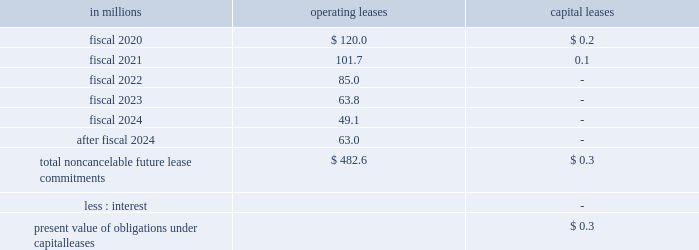As of may 26 , 2019 , we expect to pay approximately $ 2.0 million of unrecognized tax benefit liabilities and accrued interest within the next 12 months .
We are not able to reasonably estimate the timing of future cash flows beyond 12 months due to uncertainties in the timing of tax audit outcomes .
The remaining amount of our unrecognized tax liability was classified in other liabilities .
We report accrued interest and penalties related to unrecognized tax benefit liabilities in income tax expense .
For fiscal 2019 , we recognized $ 0.5 million of tax-related net interest and penalties , and had $ 26.0 million of accrued interest and penalties as of may 26 , 2019 .
For fiscal 2018 , we recognized a net benefit of $ 3.1 million of tax-related net interest and penalties , and had $ 27.3 million of accrued interest and penalties as of may 27 , 2018 .
Note 15 .
Leases , other commitments , and contingencies our leases are generally for warehouse space and equipment .
Rent expense under all operating leases from continuing operations was $ 184.9 million in fiscal 2019 , $ 189.4 million in fiscal 2018 , and $ 188.1 million in fiscal 2017 .
Some operating leases require payment of property taxes , insurance , and maintenance costs in addition to the rent payments .
Contingent and escalation rent in excess of minimum rent payments and sublease income netted in rent expense were insignificant .
Noncancelable future lease commitments are : in millions operating leases capital leases .
Depreciation on capital leases is recorded as depreciation expense in our results of operations .
As of may 26 , 2019 , we have issued guarantees and comfort letters of $ 681.6 million for the debt and other obligations of consolidated subsidiaries , and guarantees and comfort letters of $ 133.9 million for the debt and other obligations of non-consolidated affiliates , mainly cpw .
In addition , off-balance sheet arrangements are generally limited to the future payments under non-cancelable operating leases , which totaled $ 482.6 million as of may 26 , 2019 .
Note 16 .
Business segment and geographic information we operate in the packaged foods industry .
Our operating segments are as follows : north america retail ; convenience stores & foodservice ; europe & australia ; asia & latin america ; and pet .
Our north america retail operating segment reflects business with a wide variety of grocery stores , mass merchandisers , membership stores , natural food chains , drug , dollar and discount chains , and e-commerce grocery providers .
Our product categories in this business segment are ready-to-eat cereals , refrigerated yogurt , soup , meal kits , refrigerated and frozen dough products , dessert and baking mixes , frozen pizza and pizza snacks , grain , fruit and savory snacks , and a wide variety of organic products including refrigerated yogurt , nutrition bars , meal kits , salty snacks , ready-to-eat cereal , and grain snacks. .
In 2019 what was the percent of the total noncancelable future lease commitments that was due in 2021? 
Computations: (101.7 / 482.6)
Answer: 0.21073. As of may 26 , 2019 , we expect to pay approximately $ 2.0 million of unrecognized tax benefit liabilities and accrued interest within the next 12 months .
We are not able to reasonably estimate the timing of future cash flows beyond 12 months due to uncertainties in the timing of tax audit outcomes .
The remaining amount of our unrecognized tax liability was classified in other liabilities .
We report accrued interest and penalties related to unrecognized tax benefit liabilities in income tax expense .
For fiscal 2019 , we recognized $ 0.5 million of tax-related net interest and penalties , and had $ 26.0 million of accrued interest and penalties as of may 26 , 2019 .
For fiscal 2018 , we recognized a net benefit of $ 3.1 million of tax-related net interest and penalties , and had $ 27.3 million of accrued interest and penalties as of may 27 , 2018 .
Note 15 .
Leases , other commitments , and contingencies our leases are generally for warehouse space and equipment .
Rent expense under all operating leases from continuing operations was $ 184.9 million in fiscal 2019 , $ 189.4 million in fiscal 2018 , and $ 188.1 million in fiscal 2017 .
Some operating leases require payment of property taxes , insurance , and maintenance costs in addition to the rent payments .
Contingent and escalation rent in excess of minimum rent payments and sublease income netted in rent expense were insignificant .
Noncancelable future lease commitments are : in millions operating leases capital leases .
Depreciation on capital leases is recorded as depreciation expense in our results of operations .
As of may 26 , 2019 , we have issued guarantees and comfort letters of $ 681.6 million for the debt and other obligations of consolidated subsidiaries , and guarantees and comfort letters of $ 133.9 million for the debt and other obligations of non-consolidated affiliates , mainly cpw .
In addition , off-balance sheet arrangements are generally limited to the future payments under non-cancelable operating leases , which totaled $ 482.6 million as of may 26 , 2019 .
Note 16 .
Business segment and geographic information we operate in the packaged foods industry .
Our operating segments are as follows : north america retail ; convenience stores & foodservice ; europe & australia ; asia & latin america ; and pet .
Our north america retail operating segment reflects business with a wide variety of grocery stores , mass merchandisers , membership stores , natural food chains , drug , dollar and discount chains , and e-commerce grocery providers .
Our product categories in this business segment are ready-to-eat cereals , refrigerated yogurt , soup , meal kits , refrigerated and frozen dough products , dessert and baking mixes , frozen pizza and pizza snacks , grain , fruit and savory snacks , and a wide variety of organic products including refrigerated yogurt , nutrition bars , meal kits , salty snacks , ready-to-eat cereal , and grain snacks. .
What is the total rent expense for all operating leases from continuing operations from 2017 to 2019? 
Computations: ((188.1 + 189.4) + 184.9)
Answer: 562.4. 